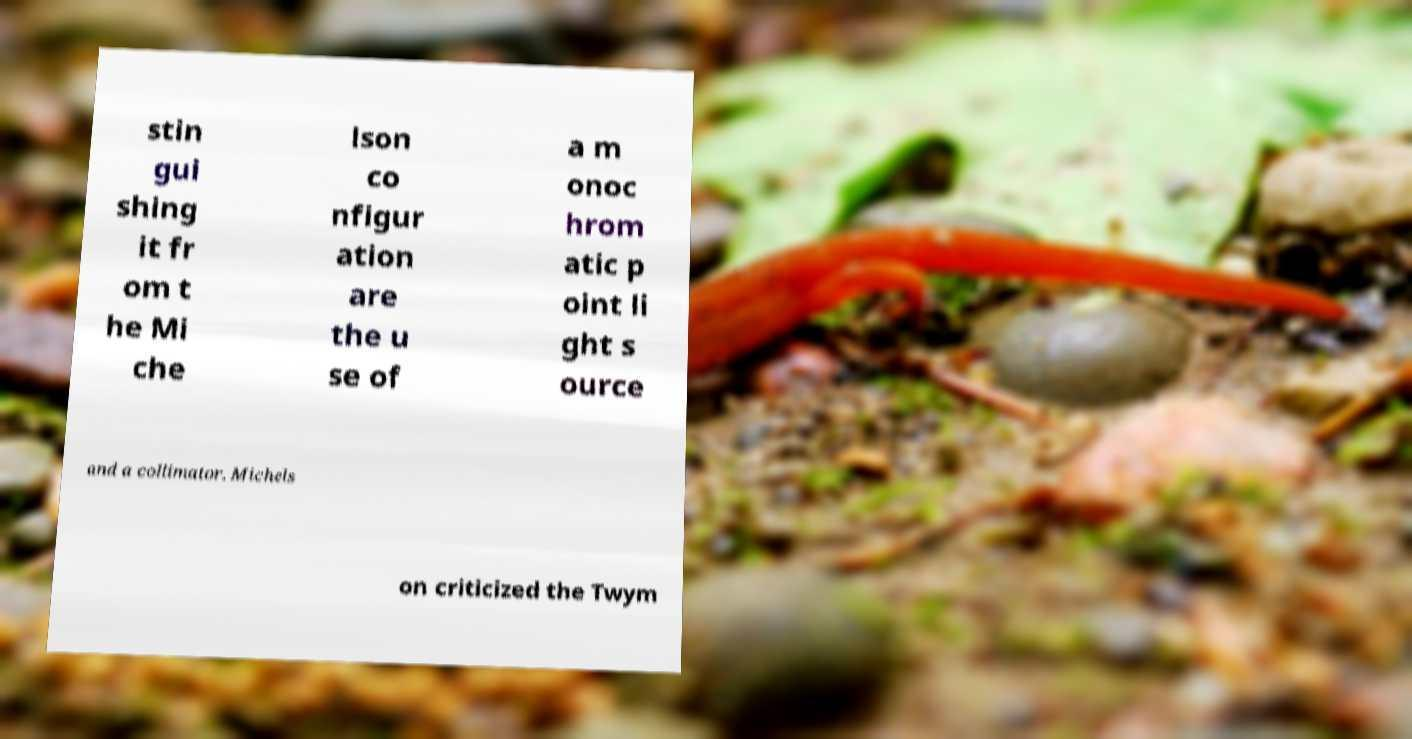Can you accurately transcribe the text from the provided image for me? stin gui shing it fr om t he Mi che lson co nfigur ation are the u se of a m onoc hrom atic p oint li ght s ource and a collimator. Michels on criticized the Twym 